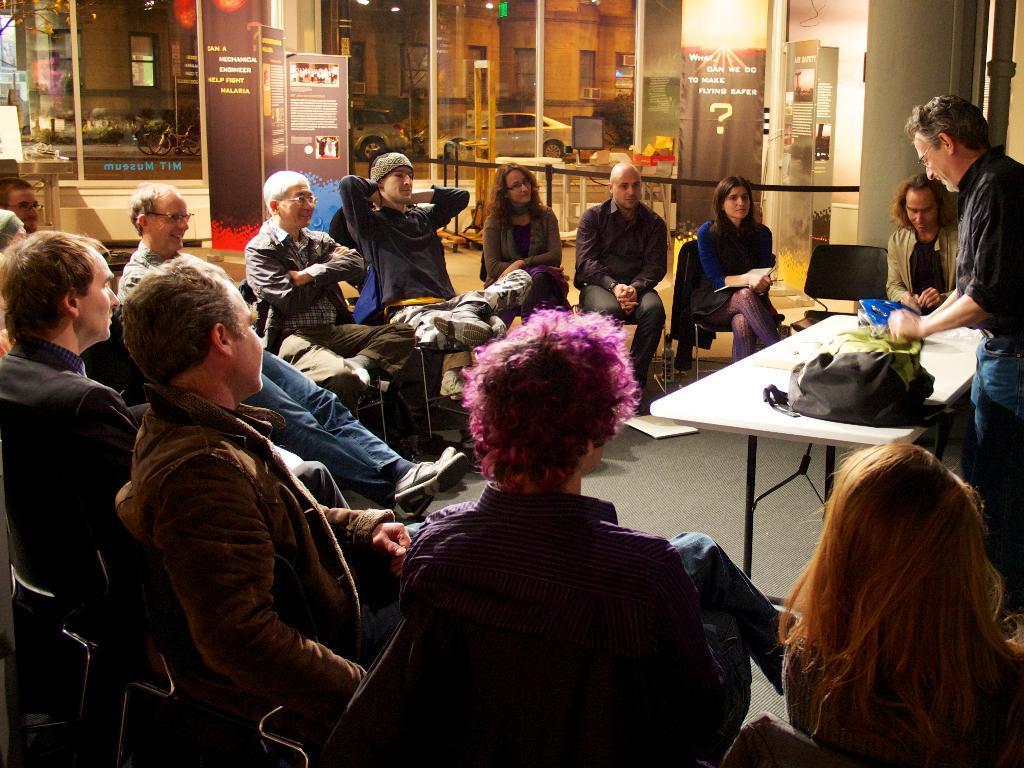Can you describe this image briefly? There are people sitting on chairs and this man standing,in front of this man we can see bags and objects on the table. In the background we can see banners,boards,glass,vehicles and windows. 